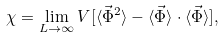Convert formula to latex. <formula><loc_0><loc_0><loc_500><loc_500>\chi = \lim _ { L \to \infty } V [ \langle \vec { \Phi } ^ { 2 } \rangle - \langle \vec { \Phi } \rangle \cdot \langle \vec { \Phi } \rangle ] ,</formula> 